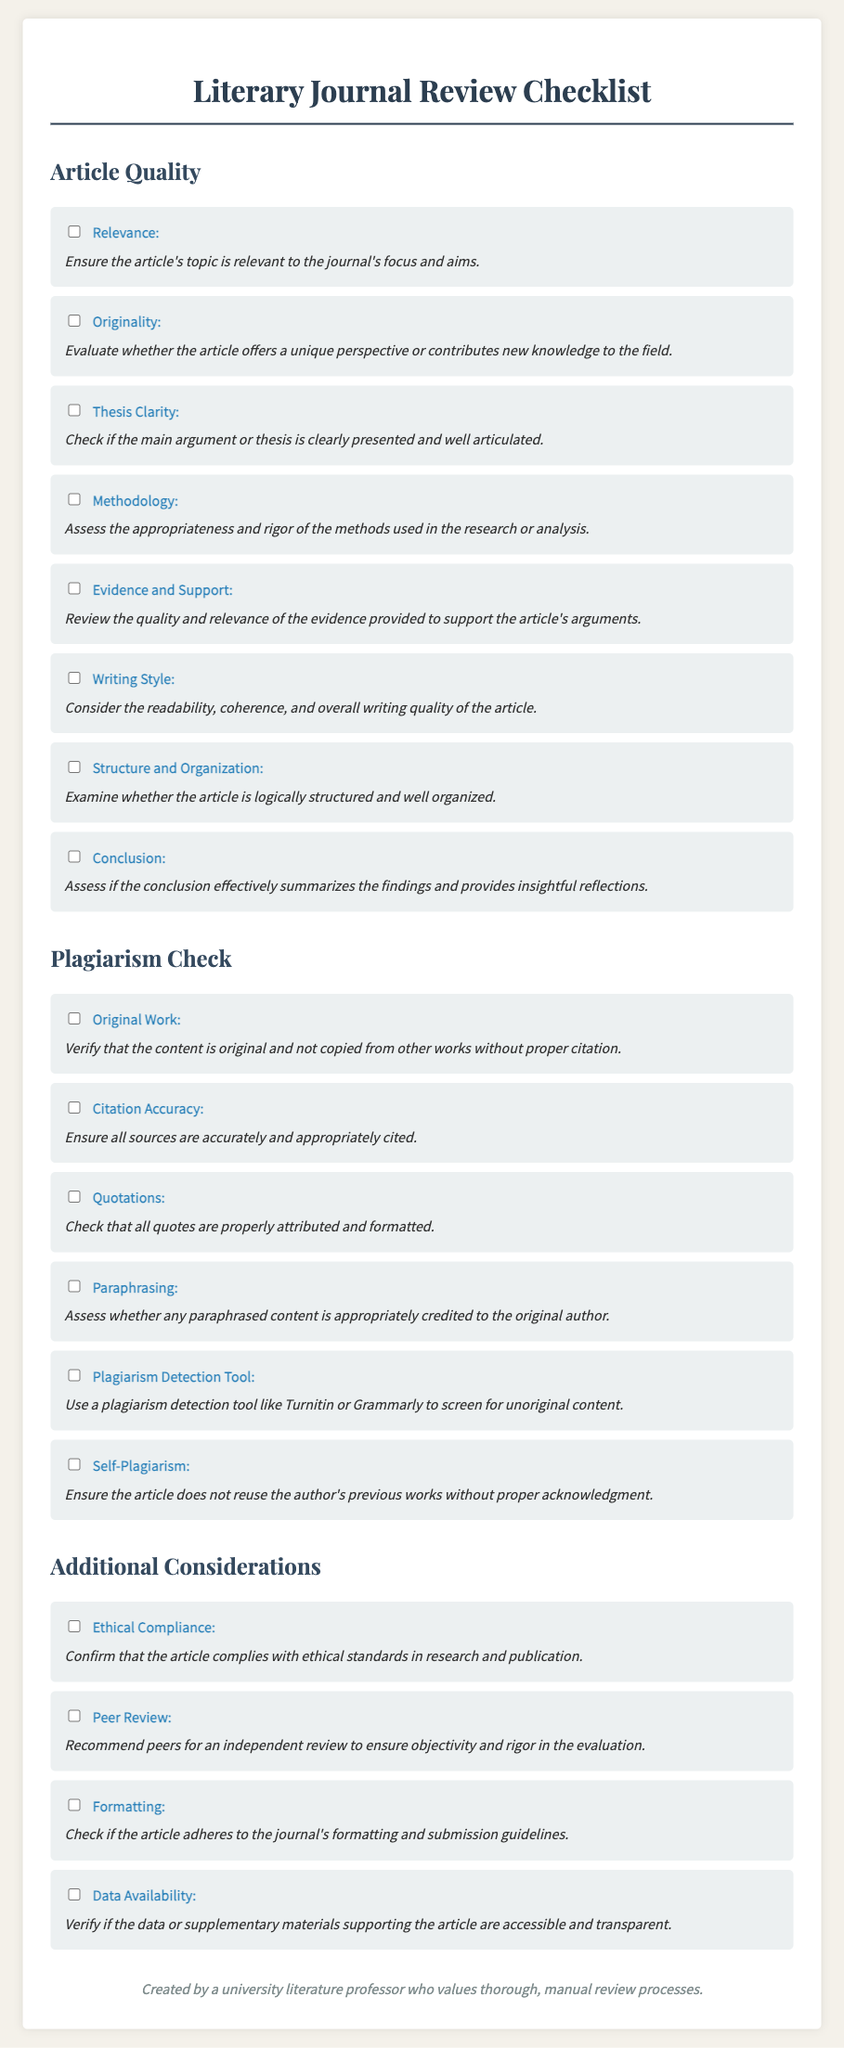What are the two main sections of the checklist? The document is divided into two main sections: Article Quality and Plagiarism Check.
Answer: Article Quality, Plagiarism Check How many criteria are listed under Article Quality? There are eight criteria listed under the Article Quality section of the checklist.
Answer: eight What does the "Relevance" criterion assess? The "Relevance" criterion ensures the article's topic is relevant to the journal's focus and aims.
Answer: relevance to the journal's focus and aims What is the purpose of the "Plagiarism Detection Tool" criterion? This criterion suggests using a tool to screen for unoriginal content.
Answer: screen for unoriginal content What does the "Self-Plagiarism" criterion check for? It checks whether the article reuses the author's previous works without proper acknowledgment.
Answer: reuse of previous works without acknowledgment How many criteria are included in the Plagiarism Check section? There are six criteria listed in the Plagiarism Check section.
Answer: six What is the last criterion under Additional Considerations? The last criterion verifies if the data or supplementary materials are accessible and transparent.
Answer: Data Availability What does "Conclusion" evaluate in the Article Quality section? It assesses if the conclusion effectively summarizes the findings and provides insightful reflections.
Answer: effective summary and insightful reflections How many total sections are in the checklist? The checklist contains three sections: Article Quality, Plagiarism Check, and Additional Considerations.
Answer: three 